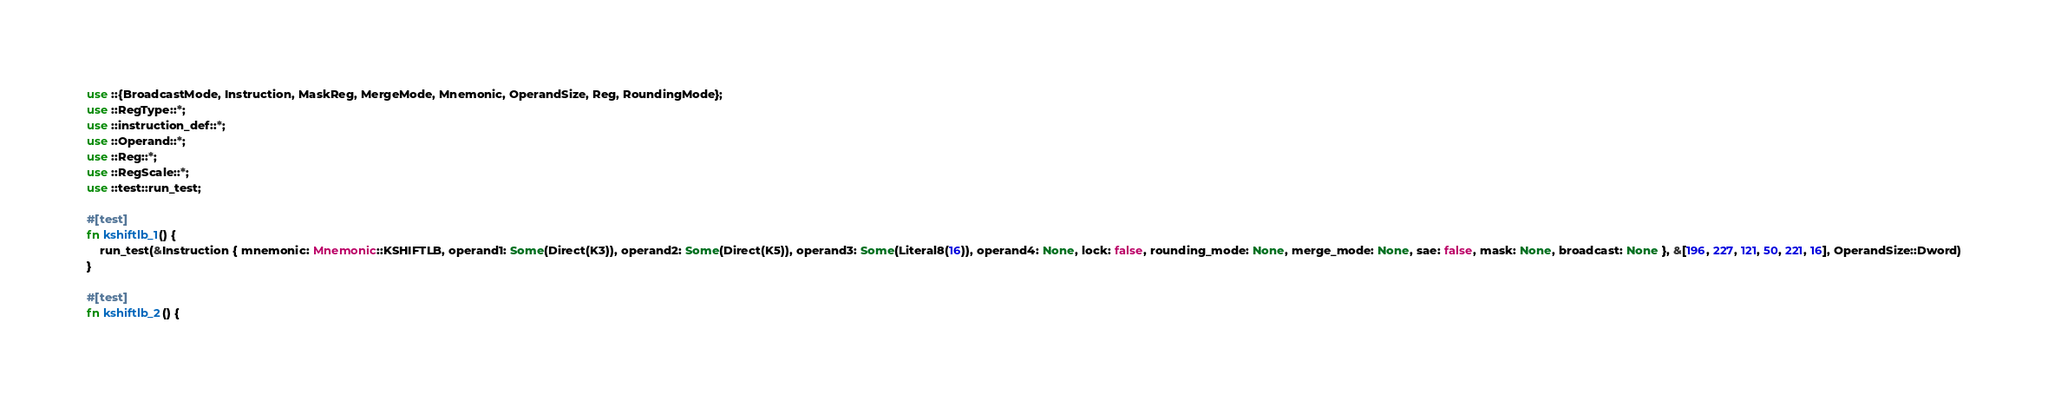<code> <loc_0><loc_0><loc_500><loc_500><_Rust_>use ::{BroadcastMode, Instruction, MaskReg, MergeMode, Mnemonic, OperandSize, Reg, RoundingMode};
use ::RegType::*;
use ::instruction_def::*;
use ::Operand::*;
use ::Reg::*;
use ::RegScale::*;
use ::test::run_test;

#[test]
fn kshiftlb_1() {
    run_test(&Instruction { mnemonic: Mnemonic::KSHIFTLB, operand1: Some(Direct(K3)), operand2: Some(Direct(K5)), operand3: Some(Literal8(16)), operand4: None, lock: false, rounding_mode: None, merge_mode: None, sae: false, mask: None, broadcast: None }, &[196, 227, 121, 50, 221, 16], OperandSize::Dword)
}

#[test]
fn kshiftlb_2() {</code> 